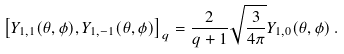<formula> <loc_0><loc_0><loc_500><loc_500>\left [ Y _ { 1 , 1 } ( \theta , \phi ) , Y _ { 1 , - 1 } ( \theta , \phi ) \right ] _ { q } = \frac { 2 } { q + 1 } \sqrt { \frac { 3 } { 4 \pi } } Y _ { 1 , 0 } ( \theta , \phi ) \, .</formula> 